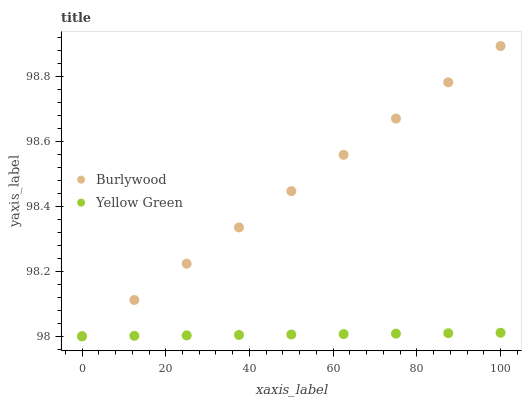Does Yellow Green have the minimum area under the curve?
Answer yes or no. Yes. Does Burlywood have the maximum area under the curve?
Answer yes or no. Yes. Does Yellow Green have the maximum area under the curve?
Answer yes or no. No. Is Burlywood the smoothest?
Answer yes or no. Yes. Is Yellow Green the roughest?
Answer yes or no. Yes. Does Burlywood have the lowest value?
Answer yes or no. Yes. Does Burlywood have the highest value?
Answer yes or no. Yes. Does Yellow Green have the highest value?
Answer yes or no. No. Does Yellow Green intersect Burlywood?
Answer yes or no. Yes. Is Yellow Green less than Burlywood?
Answer yes or no. No. Is Yellow Green greater than Burlywood?
Answer yes or no. No. 